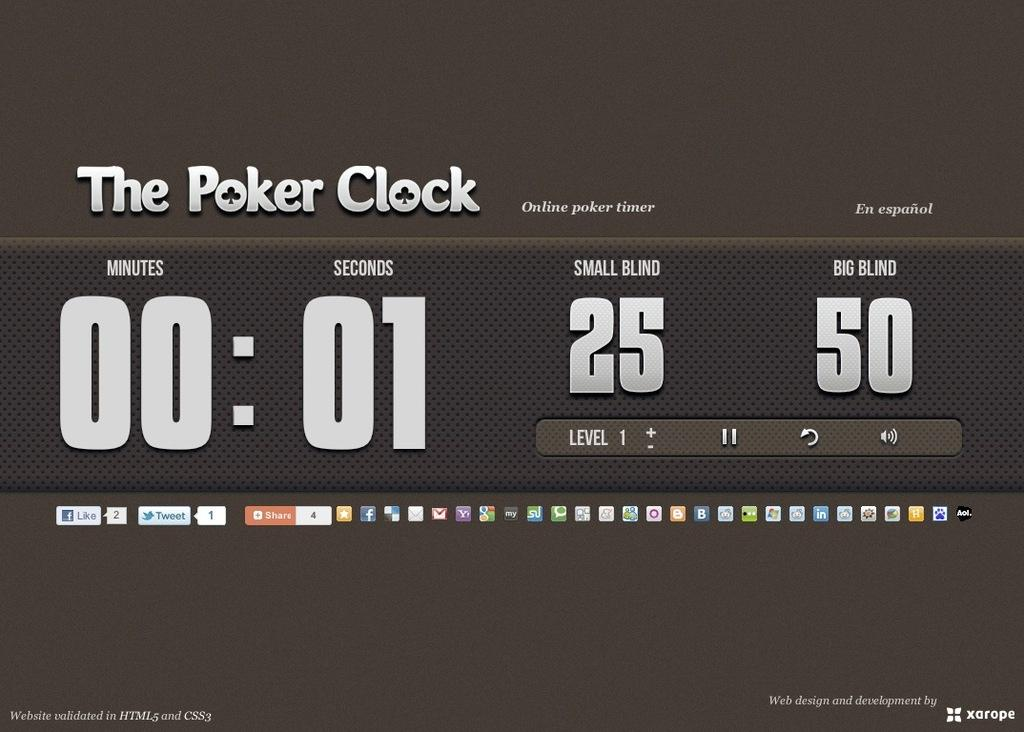<image>
Create a compact narrative representing the image presented. A screen shows an online poker timer or clock. 